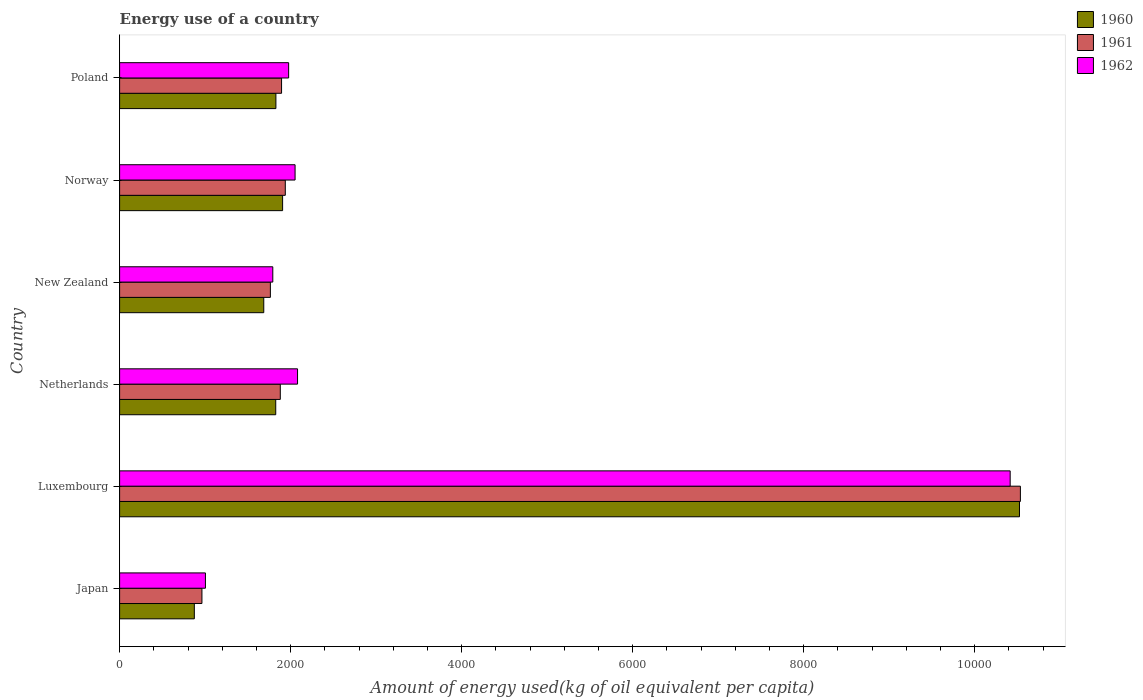How many different coloured bars are there?
Ensure brevity in your answer.  3. Are the number of bars per tick equal to the number of legend labels?
Make the answer very short. Yes. How many bars are there on the 6th tick from the bottom?
Provide a succinct answer. 3. What is the label of the 3rd group of bars from the top?
Offer a very short reply. New Zealand. In how many cases, is the number of bars for a given country not equal to the number of legend labels?
Offer a terse response. 0. What is the amount of energy used in in 1961 in Norway?
Keep it short and to the point. 1937.64. Across all countries, what is the maximum amount of energy used in in 1961?
Provide a short and direct response. 1.05e+04. Across all countries, what is the minimum amount of energy used in in 1960?
Give a very brief answer. 873.91. In which country was the amount of energy used in in 1962 maximum?
Offer a very short reply. Luxembourg. In which country was the amount of energy used in in 1961 minimum?
Make the answer very short. Japan. What is the total amount of energy used in in 1962 in the graph?
Ensure brevity in your answer.  1.93e+04. What is the difference between the amount of energy used in in 1962 in Norway and that in Poland?
Ensure brevity in your answer.  75.19. What is the difference between the amount of energy used in in 1960 in New Zealand and the amount of energy used in in 1961 in Japan?
Keep it short and to the point. 722.88. What is the average amount of energy used in in 1962 per country?
Offer a very short reply. 3219.95. What is the difference between the amount of energy used in in 1960 and amount of energy used in in 1962 in Netherlands?
Give a very brief answer. -255.08. In how many countries, is the amount of energy used in in 1962 greater than 1600 kg?
Offer a terse response. 5. What is the ratio of the amount of energy used in in 1960 in Luxembourg to that in Poland?
Your answer should be very brief. 5.76. What is the difference between the highest and the second highest amount of energy used in in 1962?
Make the answer very short. 8333.53. What is the difference between the highest and the lowest amount of energy used in in 1962?
Your answer should be compact. 9410.79. Is the sum of the amount of energy used in in 1961 in Japan and New Zealand greater than the maximum amount of energy used in in 1962 across all countries?
Keep it short and to the point. No. Is it the case that in every country, the sum of the amount of energy used in in 1960 and amount of energy used in in 1961 is greater than the amount of energy used in in 1962?
Provide a short and direct response. Yes. Are all the bars in the graph horizontal?
Your answer should be very brief. Yes. What is the difference between two consecutive major ticks on the X-axis?
Provide a short and direct response. 2000. Are the values on the major ticks of X-axis written in scientific E-notation?
Give a very brief answer. No. Does the graph contain any zero values?
Your response must be concise. No. Does the graph contain grids?
Your answer should be very brief. No. How are the legend labels stacked?
Your answer should be compact. Vertical. What is the title of the graph?
Provide a succinct answer. Energy use of a country. Does "1999" appear as one of the legend labels in the graph?
Offer a very short reply. No. What is the label or title of the X-axis?
Offer a terse response. Amount of energy used(kg of oil equivalent per capita). What is the label or title of the Y-axis?
Your answer should be very brief. Country. What is the Amount of energy used(kg of oil equivalent per capita) of 1960 in Japan?
Offer a terse response. 873.91. What is the Amount of energy used(kg of oil equivalent per capita) in 1961 in Japan?
Give a very brief answer. 962.91. What is the Amount of energy used(kg of oil equivalent per capita) of 1962 in Japan?
Offer a terse response. 1003.75. What is the Amount of energy used(kg of oil equivalent per capita) of 1960 in Luxembourg?
Give a very brief answer. 1.05e+04. What is the Amount of energy used(kg of oil equivalent per capita) in 1961 in Luxembourg?
Ensure brevity in your answer.  1.05e+04. What is the Amount of energy used(kg of oil equivalent per capita) of 1962 in Luxembourg?
Give a very brief answer. 1.04e+04. What is the Amount of energy used(kg of oil equivalent per capita) in 1960 in Netherlands?
Provide a succinct answer. 1825.93. What is the Amount of energy used(kg of oil equivalent per capita) of 1961 in Netherlands?
Your answer should be very brief. 1879.15. What is the Amount of energy used(kg of oil equivalent per capita) of 1962 in Netherlands?
Your answer should be compact. 2081.01. What is the Amount of energy used(kg of oil equivalent per capita) of 1960 in New Zealand?
Ensure brevity in your answer.  1685.79. What is the Amount of energy used(kg of oil equivalent per capita) in 1961 in New Zealand?
Offer a terse response. 1763.26. What is the Amount of energy used(kg of oil equivalent per capita) of 1962 in New Zealand?
Provide a succinct answer. 1791.46. What is the Amount of energy used(kg of oil equivalent per capita) in 1960 in Norway?
Make the answer very short. 1906.17. What is the Amount of energy used(kg of oil equivalent per capita) in 1961 in Norway?
Make the answer very short. 1937.64. What is the Amount of energy used(kg of oil equivalent per capita) in 1962 in Norway?
Make the answer very short. 2052.05. What is the Amount of energy used(kg of oil equivalent per capita) in 1960 in Poland?
Ensure brevity in your answer.  1827.94. What is the Amount of energy used(kg of oil equivalent per capita) of 1961 in Poland?
Ensure brevity in your answer.  1894.06. What is the Amount of energy used(kg of oil equivalent per capita) in 1962 in Poland?
Ensure brevity in your answer.  1976.86. Across all countries, what is the maximum Amount of energy used(kg of oil equivalent per capita) in 1960?
Ensure brevity in your answer.  1.05e+04. Across all countries, what is the maximum Amount of energy used(kg of oil equivalent per capita) of 1961?
Keep it short and to the point. 1.05e+04. Across all countries, what is the maximum Amount of energy used(kg of oil equivalent per capita) in 1962?
Offer a very short reply. 1.04e+04. Across all countries, what is the minimum Amount of energy used(kg of oil equivalent per capita) in 1960?
Offer a terse response. 873.91. Across all countries, what is the minimum Amount of energy used(kg of oil equivalent per capita) of 1961?
Provide a succinct answer. 962.91. Across all countries, what is the minimum Amount of energy used(kg of oil equivalent per capita) in 1962?
Give a very brief answer. 1003.75. What is the total Amount of energy used(kg of oil equivalent per capita) in 1960 in the graph?
Your answer should be compact. 1.86e+04. What is the total Amount of energy used(kg of oil equivalent per capita) of 1961 in the graph?
Offer a very short reply. 1.90e+04. What is the total Amount of energy used(kg of oil equivalent per capita) of 1962 in the graph?
Offer a very short reply. 1.93e+04. What is the difference between the Amount of energy used(kg of oil equivalent per capita) in 1960 in Japan and that in Luxembourg?
Offer a very short reply. -9649.5. What is the difference between the Amount of energy used(kg of oil equivalent per capita) in 1961 in Japan and that in Luxembourg?
Ensure brevity in your answer.  -9571.11. What is the difference between the Amount of energy used(kg of oil equivalent per capita) of 1962 in Japan and that in Luxembourg?
Provide a short and direct response. -9410.79. What is the difference between the Amount of energy used(kg of oil equivalent per capita) of 1960 in Japan and that in Netherlands?
Ensure brevity in your answer.  -952.02. What is the difference between the Amount of energy used(kg of oil equivalent per capita) in 1961 in Japan and that in Netherlands?
Provide a succinct answer. -916.24. What is the difference between the Amount of energy used(kg of oil equivalent per capita) of 1962 in Japan and that in Netherlands?
Provide a short and direct response. -1077.26. What is the difference between the Amount of energy used(kg of oil equivalent per capita) of 1960 in Japan and that in New Zealand?
Your answer should be very brief. -811.88. What is the difference between the Amount of energy used(kg of oil equivalent per capita) in 1961 in Japan and that in New Zealand?
Offer a very short reply. -800.35. What is the difference between the Amount of energy used(kg of oil equivalent per capita) in 1962 in Japan and that in New Zealand?
Provide a succinct answer. -787.71. What is the difference between the Amount of energy used(kg of oil equivalent per capita) of 1960 in Japan and that in Norway?
Keep it short and to the point. -1032.26. What is the difference between the Amount of energy used(kg of oil equivalent per capita) in 1961 in Japan and that in Norway?
Your response must be concise. -974.74. What is the difference between the Amount of energy used(kg of oil equivalent per capita) of 1962 in Japan and that in Norway?
Give a very brief answer. -1048.3. What is the difference between the Amount of energy used(kg of oil equivalent per capita) of 1960 in Japan and that in Poland?
Your answer should be very brief. -954.03. What is the difference between the Amount of energy used(kg of oil equivalent per capita) in 1961 in Japan and that in Poland?
Provide a succinct answer. -931.15. What is the difference between the Amount of energy used(kg of oil equivalent per capita) in 1962 in Japan and that in Poland?
Ensure brevity in your answer.  -973.11. What is the difference between the Amount of energy used(kg of oil equivalent per capita) in 1960 in Luxembourg and that in Netherlands?
Your response must be concise. 8697.47. What is the difference between the Amount of energy used(kg of oil equivalent per capita) in 1961 in Luxembourg and that in Netherlands?
Provide a succinct answer. 8654.87. What is the difference between the Amount of energy used(kg of oil equivalent per capita) of 1962 in Luxembourg and that in Netherlands?
Make the answer very short. 8333.53. What is the difference between the Amount of energy used(kg of oil equivalent per capita) of 1960 in Luxembourg and that in New Zealand?
Keep it short and to the point. 8837.62. What is the difference between the Amount of energy used(kg of oil equivalent per capita) of 1961 in Luxembourg and that in New Zealand?
Your answer should be compact. 8770.76. What is the difference between the Amount of energy used(kg of oil equivalent per capita) of 1962 in Luxembourg and that in New Zealand?
Your answer should be very brief. 8623.08. What is the difference between the Amount of energy used(kg of oil equivalent per capita) in 1960 in Luxembourg and that in Norway?
Your answer should be compact. 8617.23. What is the difference between the Amount of energy used(kg of oil equivalent per capita) in 1961 in Luxembourg and that in Norway?
Your answer should be compact. 8596.37. What is the difference between the Amount of energy used(kg of oil equivalent per capita) in 1962 in Luxembourg and that in Norway?
Keep it short and to the point. 8362.49. What is the difference between the Amount of energy used(kg of oil equivalent per capita) of 1960 in Luxembourg and that in Poland?
Provide a short and direct response. 8695.47. What is the difference between the Amount of energy used(kg of oil equivalent per capita) of 1961 in Luxembourg and that in Poland?
Make the answer very short. 8639.96. What is the difference between the Amount of energy used(kg of oil equivalent per capita) of 1962 in Luxembourg and that in Poland?
Keep it short and to the point. 8437.68. What is the difference between the Amount of energy used(kg of oil equivalent per capita) of 1960 in Netherlands and that in New Zealand?
Your answer should be compact. 140.15. What is the difference between the Amount of energy used(kg of oil equivalent per capita) in 1961 in Netherlands and that in New Zealand?
Keep it short and to the point. 115.89. What is the difference between the Amount of energy used(kg of oil equivalent per capita) in 1962 in Netherlands and that in New Zealand?
Your response must be concise. 289.55. What is the difference between the Amount of energy used(kg of oil equivalent per capita) in 1960 in Netherlands and that in Norway?
Provide a short and direct response. -80.24. What is the difference between the Amount of energy used(kg of oil equivalent per capita) in 1961 in Netherlands and that in Norway?
Your answer should be very brief. -58.49. What is the difference between the Amount of energy used(kg of oil equivalent per capita) in 1962 in Netherlands and that in Norway?
Offer a very short reply. 28.96. What is the difference between the Amount of energy used(kg of oil equivalent per capita) in 1960 in Netherlands and that in Poland?
Your answer should be compact. -2. What is the difference between the Amount of energy used(kg of oil equivalent per capita) in 1961 in Netherlands and that in Poland?
Keep it short and to the point. -14.91. What is the difference between the Amount of energy used(kg of oil equivalent per capita) in 1962 in Netherlands and that in Poland?
Provide a short and direct response. 104.15. What is the difference between the Amount of energy used(kg of oil equivalent per capita) of 1960 in New Zealand and that in Norway?
Ensure brevity in your answer.  -220.39. What is the difference between the Amount of energy used(kg of oil equivalent per capita) in 1961 in New Zealand and that in Norway?
Ensure brevity in your answer.  -174.38. What is the difference between the Amount of energy used(kg of oil equivalent per capita) of 1962 in New Zealand and that in Norway?
Keep it short and to the point. -260.59. What is the difference between the Amount of energy used(kg of oil equivalent per capita) in 1960 in New Zealand and that in Poland?
Your answer should be compact. -142.15. What is the difference between the Amount of energy used(kg of oil equivalent per capita) in 1961 in New Zealand and that in Poland?
Provide a succinct answer. -130.8. What is the difference between the Amount of energy used(kg of oil equivalent per capita) in 1962 in New Zealand and that in Poland?
Offer a terse response. -185.4. What is the difference between the Amount of energy used(kg of oil equivalent per capita) of 1960 in Norway and that in Poland?
Make the answer very short. 78.24. What is the difference between the Amount of energy used(kg of oil equivalent per capita) of 1961 in Norway and that in Poland?
Give a very brief answer. 43.59. What is the difference between the Amount of energy used(kg of oil equivalent per capita) of 1962 in Norway and that in Poland?
Make the answer very short. 75.19. What is the difference between the Amount of energy used(kg of oil equivalent per capita) in 1960 in Japan and the Amount of energy used(kg of oil equivalent per capita) in 1961 in Luxembourg?
Offer a very short reply. -9660.11. What is the difference between the Amount of energy used(kg of oil equivalent per capita) in 1960 in Japan and the Amount of energy used(kg of oil equivalent per capita) in 1962 in Luxembourg?
Your response must be concise. -9540.63. What is the difference between the Amount of energy used(kg of oil equivalent per capita) of 1961 in Japan and the Amount of energy used(kg of oil equivalent per capita) of 1962 in Luxembourg?
Your answer should be very brief. -9451.63. What is the difference between the Amount of energy used(kg of oil equivalent per capita) of 1960 in Japan and the Amount of energy used(kg of oil equivalent per capita) of 1961 in Netherlands?
Keep it short and to the point. -1005.24. What is the difference between the Amount of energy used(kg of oil equivalent per capita) of 1960 in Japan and the Amount of energy used(kg of oil equivalent per capita) of 1962 in Netherlands?
Provide a succinct answer. -1207.1. What is the difference between the Amount of energy used(kg of oil equivalent per capita) in 1961 in Japan and the Amount of energy used(kg of oil equivalent per capita) in 1962 in Netherlands?
Make the answer very short. -1118.1. What is the difference between the Amount of energy used(kg of oil equivalent per capita) in 1960 in Japan and the Amount of energy used(kg of oil equivalent per capita) in 1961 in New Zealand?
Ensure brevity in your answer.  -889.35. What is the difference between the Amount of energy used(kg of oil equivalent per capita) of 1960 in Japan and the Amount of energy used(kg of oil equivalent per capita) of 1962 in New Zealand?
Your answer should be very brief. -917.55. What is the difference between the Amount of energy used(kg of oil equivalent per capita) of 1961 in Japan and the Amount of energy used(kg of oil equivalent per capita) of 1962 in New Zealand?
Ensure brevity in your answer.  -828.55. What is the difference between the Amount of energy used(kg of oil equivalent per capita) of 1960 in Japan and the Amount of energy used(kg of oil equivalent per capita) of 1961 in Norway?
Give a very brief answer. -1063.73. What is the difference between the Amount of energy used(kg of oil equivalent per capita) of 1960 in Japan and the Amount of energy used(kg of oil equivalent per capita) of 1962 in Norway?
Provide a short and direct response. -1178.14. What is the difference between the Amount of energy used(kg of oil equivalent per capita) of 1961 in Japan and the Amount of energy used(kg of oil equivalent per capita) of 1962 in Norway?
Provide a short and direct response. -1089.15. What is the difference between the Amount of energy used(kg of oil equivalent per capita) in 1960 in Japan and the Amount of energy used(kg of oil equivalent per capita) in 1961 in Poland?
Offer a very short reply. -1020.15. What is the difference between the Amount of energy used(kg of oil equivalent per capita) of 1960 in Japan and the Amount of energy used(kg of oil equivalent per capita) of 1962 in Poland?
Your answer should be compact. -1102.95. What is the difference between the Amount of energy used(kg of oil equivalent per capita) of 1961 in Japan and the Amount of energy used(kg of oil equivalent per capita) of 1962 in Poland?
Provide a short and direct response. -1013.95. What is the difference between the Amount of energy used(kg of oil equivalent per capita) of 1960 in Luxembourg and the Amount of energy used(kg of oil equivalent per capita) of 1961 in Netherlands?
Make the answer very short. 8644.26. What is the difference between the Amount of energy used(kg of oil equivalent per capita) of 1960 in Luxembourg and the Amount of energy used(kg of oil equivalent per capita) of 1962 in Netherlands?
Provide a succinct answer. 8442.4. What is the difference between the Amount of energy used(kg of oil equivalent per capita) in 1961 in Luxembourg and the Amount of energy used(kg of oil equivalent per capita) in 1962 in Netherlands?
Your response must be concise. 8453.01. What is the difference between the Amount of energy used(kg of oil equivalent per capita) of 1960 in Luxembourg and the Amount of energy used(kg of oil equivalent per capita) of 1961 in New Zealand?
Give a very brief answer. 8760.15. What is the difference between the Amount of energy used(kg of oil equivalent per capita) of 1960 in Luxembourg and the Amount of energy used(kg of oil equivalent per capita) of 1962 in New Zealand?
Your answer should be compact. 8731.95. What is the difference between the Amount of energy used(kg of oil equivalent per capita) in 1961 in Luxembourg and the Amount of energy used(kg of oil equivalent per capita) in 1962 in New Zealand?
Provide a short and direct response. 8742.56. What is the difference between the Amount of energy used(kg of oil equivalent per capita) of 1960 in Luxembourg and the Amount of energy used(kg of oil equivalent per capita) of 1961 in Norway?
Keep it short and to the point. 8585.76. What is the difference between the Amount of energy used(kg of oil equivalent per capita) of 1960 in Luxembourg and the Amount of energy used(kg of oil equivalent per capita) of 1962 in Norway?
Give a very brief answer. 8471.35. What is the difference between the Amount of energy used(kg of oil equivalent per capita) in 1961 in Luxembourg and the Amount of energy used(kg of oil equivalent per capita) in 1962 in Norway?
Your answer should be compact. 8481.96. What is the difference between the Amount of energy used(kg of oil equivalent per capita) in 1960 in Luxembourg and the Amount of energy used(kg of oil equivalent per capita) in 1961 in Poland?
Your response must be concise. 8629.35. What is the difference between the Amount of energy used(kg of oil equivalent per capita) of 1960 in Luxembourg and the Amount of energy used(kg of oil equivalent per capita) of 1962 in Poland?
Keep it short and to the point. 8546.55. What is the difference between the Amount of energy used(kg of oil equivalent per capita) in 1961 in Luxembourg and the Amount of energy used(kg of oil equivalent per capita) in 1962 in Poland?
Your answer should be very brief. 8557.16. What is the difference between the Amount of energy used(kg of oil equivalent per capita) of 1960 in Netherlands and the Amount of energy used(kg of oil equivalent per capita) of 1961 in New Zealand?
Keep it short and to the point. 62.67. What is the difference between the Amount of energy used(kg of oil equivalent per capita) in 1960 in Netherlands and the Amount of energy used(kg of oil equivalent per capita) in 1962 in New Zealand?
Offer a very short reply. 34.47. What is the difference between the Amount of energy used(kg of oil equivalent per capita) in 1961 in Netherlands and the Amount of energy used(kg of oil equivalent per capita) in 1962 in New Zealand?
Offer a terse response. 87.69. What is the difference between the Amount of energy used(kg of oil equivalent per capita) in 1960 in Netherlands and the Amount of energy used(kg of oil equivalent per capita) in 1961 in Norway?
Ensure brevity in your answer.  -111.71. What is the difference between the Amount of energy used(kg of oil equivalent per capita) in 1960 in Netherlands and the Amount of energy used(kg of oil equivalent per capita) in 1962 in Norway?
Make the answer very short. -226.12. What is the difference between the Amount of energy used(kg of oil equivalent per capita) in 1961 in Netherlands and the Amount of energy used(kg of oil equivalent per capita) in 1962 in Norway?
Give a very brief answer. -172.9. What is the difference between the Amount of energy used(kg of oil equivalent per capita) of 1960 in Netherlands and the Amount of energy used(kg of oil equivalent per capita) of 1961 in Poland?
Ensure brevity in your answer.  -68.12. What is the difference between the Amount of energy used(kg of oil equivalent per capita) of 1960 in Netherlands and the Amount of energy used(kg of oil equivalent per capita) of 1962 in Poland?
Your answer should be compact. -150.93. What is the difference between the Amount of energy used(kg of oil equivalent per capita) in 1961 in Netherlands and the Amount of energy used(kg of oil equivalent per capita) in 1962 in Poland?
Provide a short and direct response. -97.71. What is the difference between the Amount of energy used(kg of oil equivalent per capita) of 1960 in New Zealand and the Amount of energy used(kg of oil equivalent per capita) of 1961 in Norway?
Your response must be concise. -251.86. What is the difference between the Amount of energy used(kg of oil equivalent per capita) of 1960 in New Zealand and the Amount of energy used(kg of oil equivalent per capita) of 1962 in Norway?
Your response must be concise. -366.27. What is the difference between the Amount of energy used(kg of oil equivalent per capita) in 1961 in New Zealand and the Amount of energy used(kg of oil equivalent per capita) in 1962 in Norway?
Offer a very short reply. -288.79. What is the difference between the Amount of energy used(kg of oil equivalent per capita) in 1960 in New Zealand and the Amount of energy used(kg of oil equivalent per capita) in 1961 in Poland?
Give a very brief answer. -208.27. What is the difference between the Amount of energy used(kg of oil equivalent per capita) of 1960 in New Zealand and the Amount of energy used(kg of oil equivalent per capita) of 1962 in Poland?
Your answer should be compact. -291.07. What is the difference between the Amount of energy used(kg of oil equivalent per capita) in 1961 in New Zealand and the Amount of energy used(kg of oil equivalent per capita) in 1962 in Poland?
Provide a succinct answer. -213.6. What is the difference between the Amount of energy used(kg of oil equivalent per capita) in 1960 in Norway and the Amount of energy used(kg of oil equivalent per capita) in 1961 in Poland?
Your answer should be very brief. 12.12. What is the difference between the Amount of energy used(kg of oil equivalent per capita) of 1960 in Norway and the Amount of energy used(kg of oil equivalent per capita) of 1962 in Poland?
Your answer should be compact. -70.68. What is the difference between the Amount of energy used(kg of oil equivalent per capita) of 1961 in Norway and the Amount of energy used(kg of oil equivalent per capita) of 1962 in Poland?
Ensure brevity in your answer.  -39.22. What is the average Amount of energy used(kg of oil equivalent per capita) in 1960 per country?
Ensure brevity in your answer.  3107.19. What is the average Amount of energy used(kg of oil equivalent per capita) in 1961 per country?
Provide a short and direct response. 3161.84. What is the average Amount of energy used(kg of oil equivalent per capita) of 1962 per country?
Your answer should be compact. 3219.95. What is the difference between the Amount of energy used(kg of oil equivalent per capita) in 1960 and Amount of energy used(kg of oil equivalent per capita) in 1961 in Japan?
Provide a succinct answer. -89. What is the difference between the Amount of energy used(kg of oil equivalent per capita) in 1960 and Amount of energy used(kg of oil equivalent per capita) in 1962 in Japan?
Your answer should be very brief. -129.84. What is the difference between the Amount of energy used(kg of oil equivalent per capita) of 1961 and Amount of energy used(kg of oil equivalent per capita) of 1962 in Japan?
Offer a very short reply. -40.85. What is the difference between the Amount of energy used(kg of oil equivalent per capita) in 1960 and Amount of energy used(kg of oil equivalent per capita) in 1961 in Luxembourg?
Provide a succinct answer. -10.61. What is the difference between the Amount of energy used(kg of oil equivalent per capita) of 1960 and Amount of energy used(kg of oil equivalent per capita) of 1962 in Luxembourg?
Your response must be concise. 108.87. What is the difference between the Amount of energy used(kg of oil equivalent per capita) in 1961 and Amount of energy used(kg of oil equivalent per capita) in 1962 in Luxembourg?
Offer a terse response. 119.48. What is the difference between the Amount of energy used(kg of oil equivalent per capita) of 1960 and Amount of energy used(kg of oil equivalent per capita) of 1961 in Netherlands?
Give a very brief answer. -53.22. What is the difference between the Amount of energy used(kg of oil equivalent per capita) in 1960 and Amount of energy used(kg of oil equivalent per capita) in 1962 in Netherlands?
Offer a very short reply. -255.08. What is the difference between the Amount of energy used(kg of oil equivalent per capita) of 1961 and Amount of energy used(kg of oil equivalent per capita) of 1962 in Netherlands?
Your answer should be very brief. -201.86. What is the difference between the Amount of energy used(kg of oil equivalent per capita) of 1960 and Amount of energy used(kg of oil equivalent per capita) of 1961 in New Zealand?
Provide a succinct answer. -77.47. What is the difference between the Amount of energy used(kg of oil equivalent per capita) in 1960 and Amount of energy used(kg of oil equivalent per capita) in 1962 in New Zealand?
Make the answer very short. -105.67. What is the difference between the Amount of energy used(kg of oil equivalent per capita) of 1961 and Amount of energy used(kg of oil equivalent per capita) of 1962 in New Zealand?
Offer a terse response. -28.2. What is the difference between the Amount of energy used(kg of oil equivalent per capita) in 1960 and Amount of energy used(kg of oil equivalent per capita) in 1961 in Norway?
Offer a terse response. -31.47. What is the difference between the Amount of energy used(kg of oil equivalent per capita) of 1960 and Amount of energy used(kg of oil equivalent per capita) of 1962 in Norway?
Offer a terse response. -145.88. What is the difference between the Amount of energy used(kg of oil equivalent per capita) of 1961 and Amount of energy used(kg of oil equivalent per capita) of 1962 in Norway?
Give a very brief answer. -114.41. What is the difference between the Amount of energy used(kg of oil equivalent per capita) of 1960 and Amount of energy used(kg of oil equivalent per capita) of 1961 in Poland?
Keep it short and to the point. -66.12. What is the difference between the Amount of energy used(kg of oil equivalent per capita) of 1960 and Amount of energy used(kg of oil equivalent per capita) of 1962 in Poland?
Keep it short and to the point. -148.92. What is the difference between the Amount of energy used(kg of oil equivalent per capita) of 1961 and Amount of energy used(kg of oil equivalent per capita) of 1962 in Poland?
Offer a very short reply. -82.8. What is the ratio of the Amount of energy used(kg of oil equivalent per capita) in 1960 in Japan to that in Luxembourg?
Make the answer very short. 0.08. What is the ratio of the Amount of energy used(kg of oil equivalent per capita) in 1961 in Japan to that in Luxembourg?
Make the answer very short. 0.09. What is the ratio of the Amount of energy used(kg of oil equivalent per capita) in 1962 in Japan to that in Luxembourg?
Offer a very short reply. 0.1. What is the ratio of the Amount of energy used(kg of oil equivalent per capita) in 1960 in Japan to that in Netherlands?
Give a very brief answer. 0.48. What is the ratio of the Amount of energy used(kg of oil equivalent per capita) in 1961 in Japan to that in Netherlands?
Provide a succinct answer. 0.51. What is the ratio of the Amount of energy used(kg of oil equivalent per capita) of 1962 in Japan to that in Netherlands?
Your answer should be very brief. 0.48. What is the ratio of the Amount of energy used(kg of oil equivalent per capita) of 1960 in Japan to that in New Zealand?
Provide a succinct answer. 0.52. What is the ratio of the Amount of energy used(kg of oil equivalent per capita) of 1961 in Japan to that in New Zealand?
Provide a succinct answer. 0.55. What is the ratio of the Amount of energy used(kg of oil equivalent per capita) of 1962 in Japan to that in New Zealand?
Offer a terse response. 0.56. What is the ratio of the Amount of energy used(kg of oil equivalent per capita) of 1960 in Japan to that in Norway?
Your response must be concise. 0.46. What is the ratio of the Amount of energy used(kg of oil equivalent per capita) of 1961 in Japan to that in Norway?
Provide a succinct answer. 0.5. What is the ratio of the Amount of energy used(kg of oil equivalent per capita) of 1962 in Japan to that in Norway?
Your answer should be compact. 0.49. What is the ratio of the Amount of energy used(kg of oil equivalent per capita) of 1960 in Japan to that in Poland?
Give a very brief answer. 0.48. What is the ratio of the Amount of energy used(kg of oil equivalent per capita) in 1961 in Japan to that in Poland?
Give a very brief answer. 0.51. What is the ratio of the Amount of energy used(kg of oil equivalent per capita) in 1962 in Japan to that in Poland?
Provide a short and direct response. 0.51. What is the ratio of the Amount of energy used(kg of oil equivalent per capita) of 1960 in Luxembourg to that in Netherlands?
Offer a terse response. 5.76. What is the ratio of the Amount of energy used(kg of oil equivalent per capita) in 1961 in Luxembourg to that in Netherlands?
Keep it short and to the point. 5.61. What is the ratio of the Amount of energy used(kg of oil equivalent per capita) in 1962 in Luxembourg to that in Netherlands?
Your answer should be compact. 5. What is the ratio of the Amount of energy used(kg of oil equivalent per capita) in 1960 in Luxembourg to that in New Zealand?
Provide a succinct answer. 6.24. What is the ratio of the Amount of energy used(kg of oil equivalent per capita) in 1961 in Luxembourg to that in New Zealand?
Your answer should be compact. 5.97. What is the ratio of the Amount of energy used(kg of oil equivalent per capita) of 1962 in Luxembourg to that in New Zealand?
Make the answer very short. 5.81. What is the ratio of the Amount of energy used(kg of oil equivalent per capita) in 1960 in Luxembourg to that in Norway?
Your answer should be very brief. 5.52. What is the ratio of the Amount of energy used(kg of oil equivalent per capita) in 1961 in Luxembourg to that in Norway?
Your answer should be very brief. 5.44. What is the ratio of the Amount of energy used(kg of oil equivalent per capita) in 1962 in Luxembourg to that in Norway?
Your answer should be compact. 5.08. What is the ratio of the Amount of energy used(kg of oil equivalent per capita) of 1960 in Luxembourg to that in Poland?
Offer a terse response. 5.76. What is the ratio of the Amount of energy used(kg of oil equivalent per capita) of 1961 in Luxembourg to that in Poland?
Give a very brief answer. 5.56. What is the ratio of the Amount of energy used(kg of oil equivalent per capita) in 1962 in Luxembourg to that in Poland?
Keep it short and to the point. 5.27. What is the ratio of the Amount of energy used(kg of oil equivalent per capita) of 1960 in Netherlands to that in New Zealand?
Make the answer very short. 1.08. What is the ratio of the Amount of energy used(kg of oil equivalent per capita) in 1961 in Netherlands to that in New Zealand?
Your answer should be very brief. 1.07. What is the ratio of the Amount of energy used(kg of oil equivalent per capita) of 1962 in Netherlands to that in New Zealand?
Your answer should be very brief. 1.16. What is the ratio of the Amount of energy used(kg of oil equivalent per capita) of 1960 in Netherlands to that in Norway?
Give a very brief answer. 0.96. What is the ratio of the Amount of energy used(kg of oil equivalent per capita) of 1961 in Netherlands to that in Norway?
Your answer should be compact. 0.97. What is the ratio of the Amount of energy used(kg of oil equivalent per capita) of 1962 in Netherlands to that in Norway?
Make the answer very short. 1.01. What is the ratio of the Amount of energy used(kg of oil equivalent per capita) of 1962 in Netherlands to that in Poland?
Provide a succinct answer. 1.05. What is the ratio of the Amount of energy used(kg of oil equivalent per capita) of 1960 in New Zealand to that in Norway?
Ensure brevity in your answer.  0.88. What is the ratio of the Amount of energy used(kg of oil equivalent per capita) in 1961 in New Zealand to that in Norway?
Give a very brief answer. 0.91. What is the ratio of the Amount of energy used(kg of oil equivalent per capita) of 1962 in New Zealand to that in Norway?
Ensure brevity in your answer.  0.87. What is the ratio of the Amount of energy used(kg of oil equivalent per capita) of 1960 in New Zealand to that in Poland?
Provide a succinct answer. 0.92. What is the ratio of the Amount of energy used(kg of oil equivalent per capita) in 1961 in New Zealand to that in Poland?
Your response must be concise. 0.93. What is the ratio of the Amount of energy used(kg of oil equivalent per capita) in 1962 in New Zealand to that in Poland?
Offer a very short reply. 0.91. What is the ratio of the Amount of energy used(kg of oil equivalent per capita) of 1960 in Norway to that in Poland?
Keep it short and to the point. 1.04. What is the ratio of the Amount of energy used(kg of oil equivalent per capita) in 1962 in Norway to that in Poland?
Provide a succinct answer. 1.04. What is the difference between the highest and the second highest Amount of energy used(kg of oil equivalent per capita) of 1960?
Provide a short and direct response. 8617.23. What is the difference between the highest and the second highest Amount of energy used(kg of oil equivalent per capita) of 1961?
Keep it short and to the point. 8596.37. What is the difference between the highest and the second highest Amount of energy used(kg of oil equivalent per capita) of 1962?
Your answer should be very brief. 8333.53. What is the difference between the highest and the lowest Amount of energy used(kg of oil equivalent per capita) in 1960?
Your answer should be compact. 9649.5. What is the difference between the highest and the lowest Amount of energy used(kg of oil equivalent per capita) of 1961?
Offer a very short reply. 9571.11. What is the difference between the highest and the lowest Amount of energy used(kg of oil equivalent per capita) of 1962?
Offer a very short reply. 9410.79. 